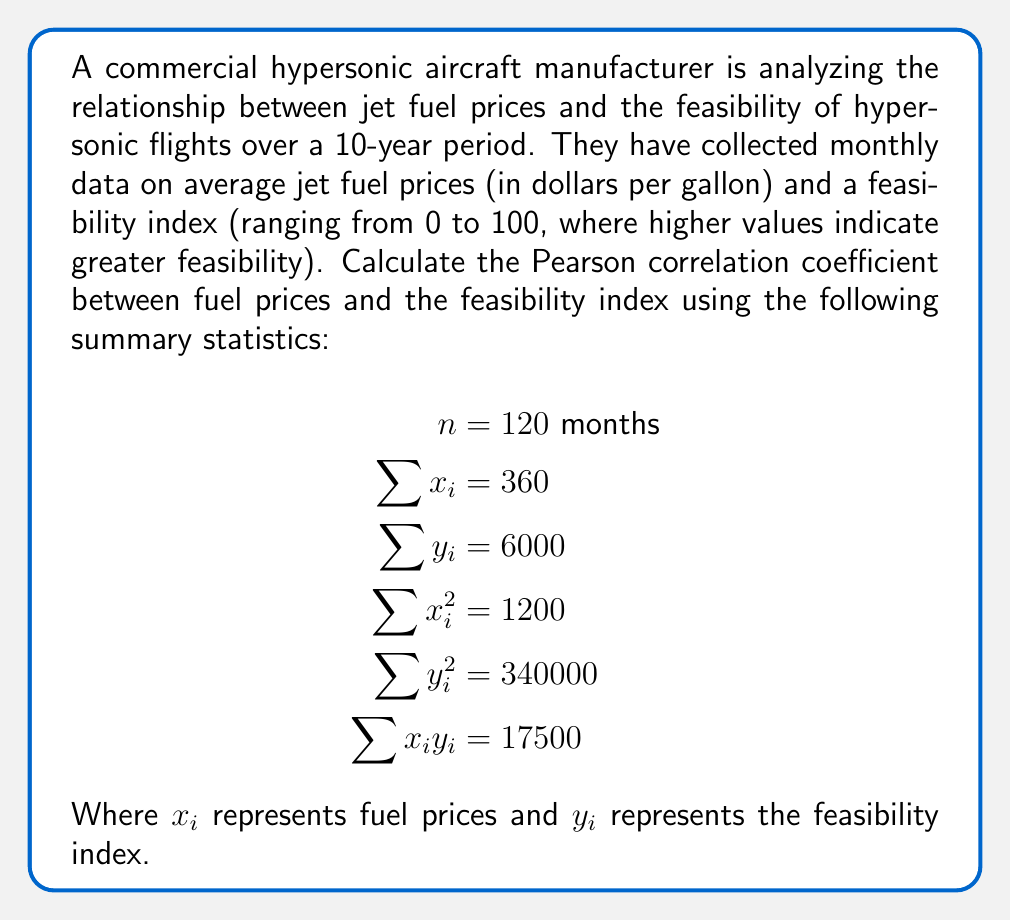Provide a solution to this math problem. To calculate the Pearson correlation coefficient, we'll use the formula:

$$r = \frac{n\sum x_iy_i - \sum x_i \sum y_i}{\sqrt{[n\sum x_i^2 - (\sum x_i)^2][n\sum y_i^2 - (\sum y_i)^2]}}$$

Let's calculate each component:

1. $n\sum x_iy_i = 120 \times 17500 = 2100000$
2. $\sum x_i \sum y_i = 360 \times 6000 = 2160000$
3. $n\sum x_i^2 = 120 \times 1200 = 144000$
4. $(\sum x_i)^2 = 360^2 = 129600$
5. $n\sum y_i^2 = 120 \times 340000 = 40800000$
6. $(\sum y_i)^2 = 6000^2 = 36000000$

Now, let's substitute these values into the formula:

$$\begin{aligned}
r &= \frac{2100000 - 2160000}{\sqrt{(144000 - 129600)(40800000 - 36000000)}} \\
&= \frac{-60000}{\sqrt{(14400)(4800000)}} \\
&= \frac{-60000}{\sqrt{69120000000}} \\
&= \frac{-60000}{262908.2258} \\
&\approx -0.2282
\end{aligned}$$
Answer: The Pearson correlation coefficient between fuel prices and the hypersonic flight feasibility index is approximately $-0.2282$. 